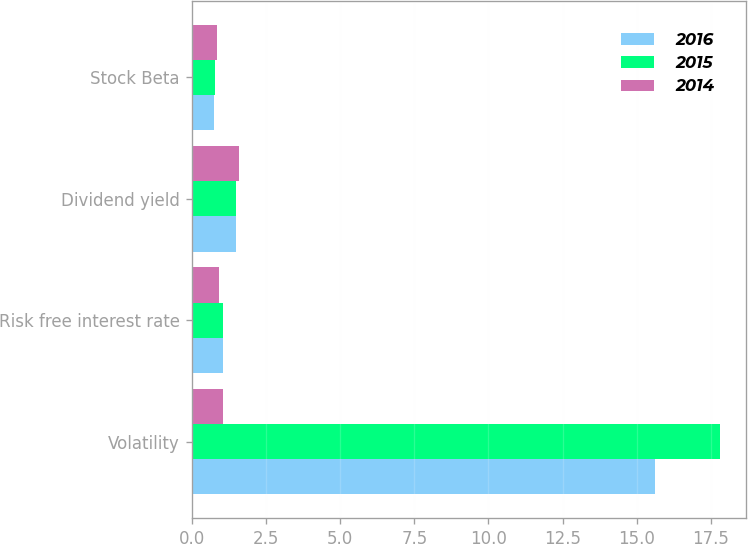Convert chart. <chart><loc_0><loc_0><loc_500><loc_500><stacked_bar_chart><ecel><fcel>Volatility<fcel>Risk free interest rate<fcel>Dividend yield<fcel>Stock Beta<nl><fcel>2016<fcel>15.6<fcel>1.06<fcel>1.5<fcel>0.74<nl><fcel>2015<fcel>17.8<fcel>1.06<fcel>1.5<fcel>0.77<nl><fcel>2014<fcel>1.06<fcel>0.91<fcel>1.6<fcel>0.84<nl></chart> 